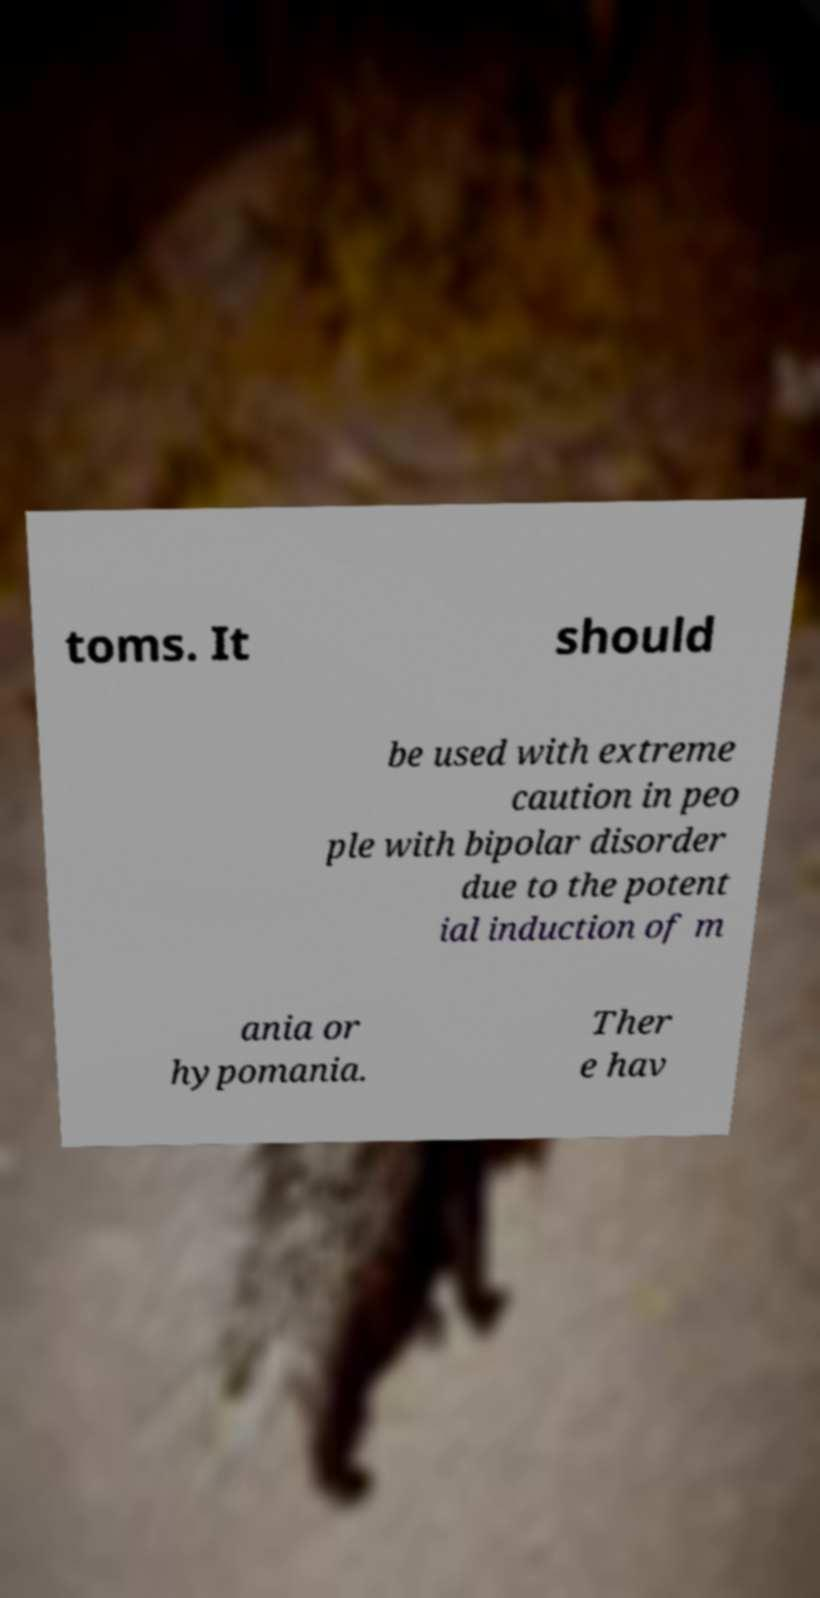Please read and relay the text visible in this image. What does it say? toms. It should be used with extreme caution in peo ple with bipolar disorder due to the potent ial induction of m ania or hypomania. Ther e hav 